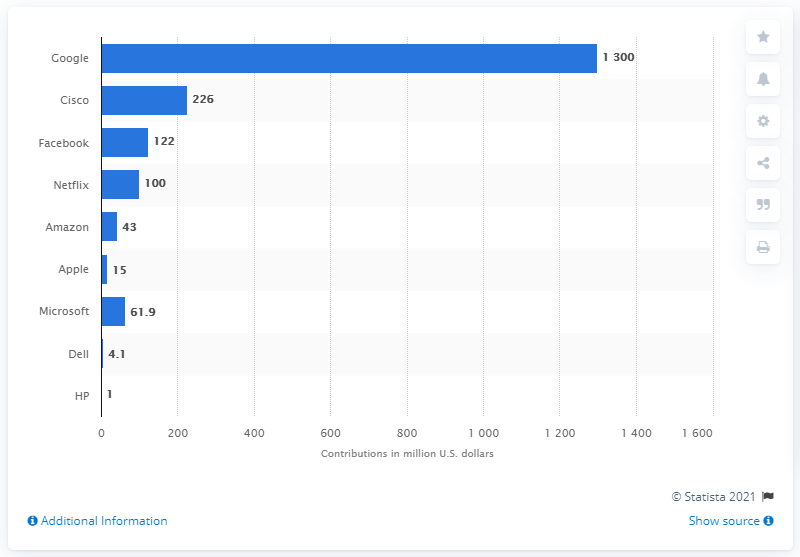Highlight a few significant elements in this photo. Google has donated a total of $1300 to fight the coronavirus. 